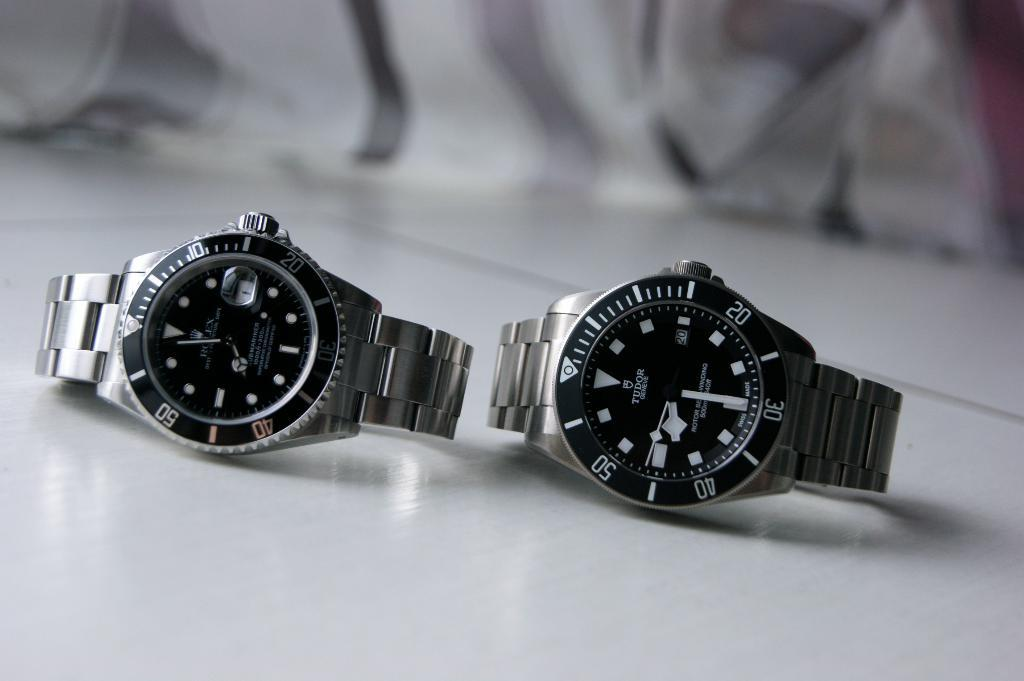<image>
Create a compact narrative representing the image presented. Two silver and black wristwatches with one whose hands are on the numbers 30 and 40. 